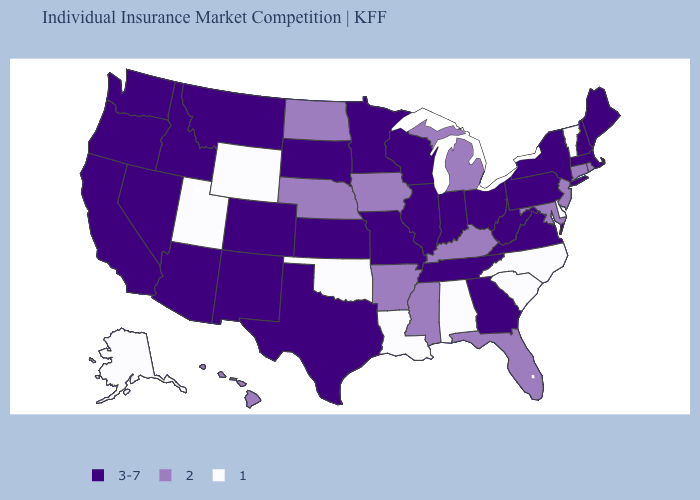Name the states that have a value in the range 2?
Answer briefly. Arkansas, Connecticut, Florida, Hawaii, Iowa, Kentucky, Maryland, Michigan, Mississippi, Nebraska, New Jersey, North Dakota, Rhode Island. Does Nebraska have the highest value in the MidWest?
Quick response, please. No. Name the states that have a value in the range 3-7?
Give a very brief answer. Arizona, California, Colorado, Georgia, Idaho, Illinois, Indiana, Kansas, Maine, Massachusetts, Minnesota, Missouri, Montana, Nevada, New Hampshire, New Mexico, New York, Ohio, Oregon, Pennsylvania, South Dakota, Tennessee, Texas, Virginia, Washington, West Virginia, Wisconsin. What is the value of New Mexico?
Short answer required. 3-7. What is the value of Texas?
Concise answer only. 3-7. Name the states that have a value in the range 1?
Short answer required. Alabama, Alaska, Delaware, Louisiana, North Carolina, Oklahoma, South Carolina, Utah, Vermont, Wyoming. What is the highest value in states that border Ohio?
Answer briefly. 3-7. Name the states that have a value in the range 3-7?
Answer briefly. Arizona, California, Colorado, Georgia, Idaho, Illinois, Indiana, Kansas, Maine, Massachusetts, Minnesota, Missouri, Montana, Nevada, New Hampshire, New Mexico, New York, Ohio, Oregon, Pennsylvania, South Dakota, Tennessee, Texas, Virginia, Washington, West Virginia, Wisconsin. What is the value of Virginia?
Concise answer only. 3-7. Does Delaware have the highest value in the USA?
Short answer required. No. Does Virginia have the highest value in the USA?
Short answer required. Yes. What is the lowest value in states that border Alabama?
Be succinct. 2. Does Utah have the same value as Iowa?
Quick response, please. No. What is the lowest value in states that border Wisconsin?
Give a very brief answer. 2. What is the highest value in the USA?
Concise answer only. 3-7. 